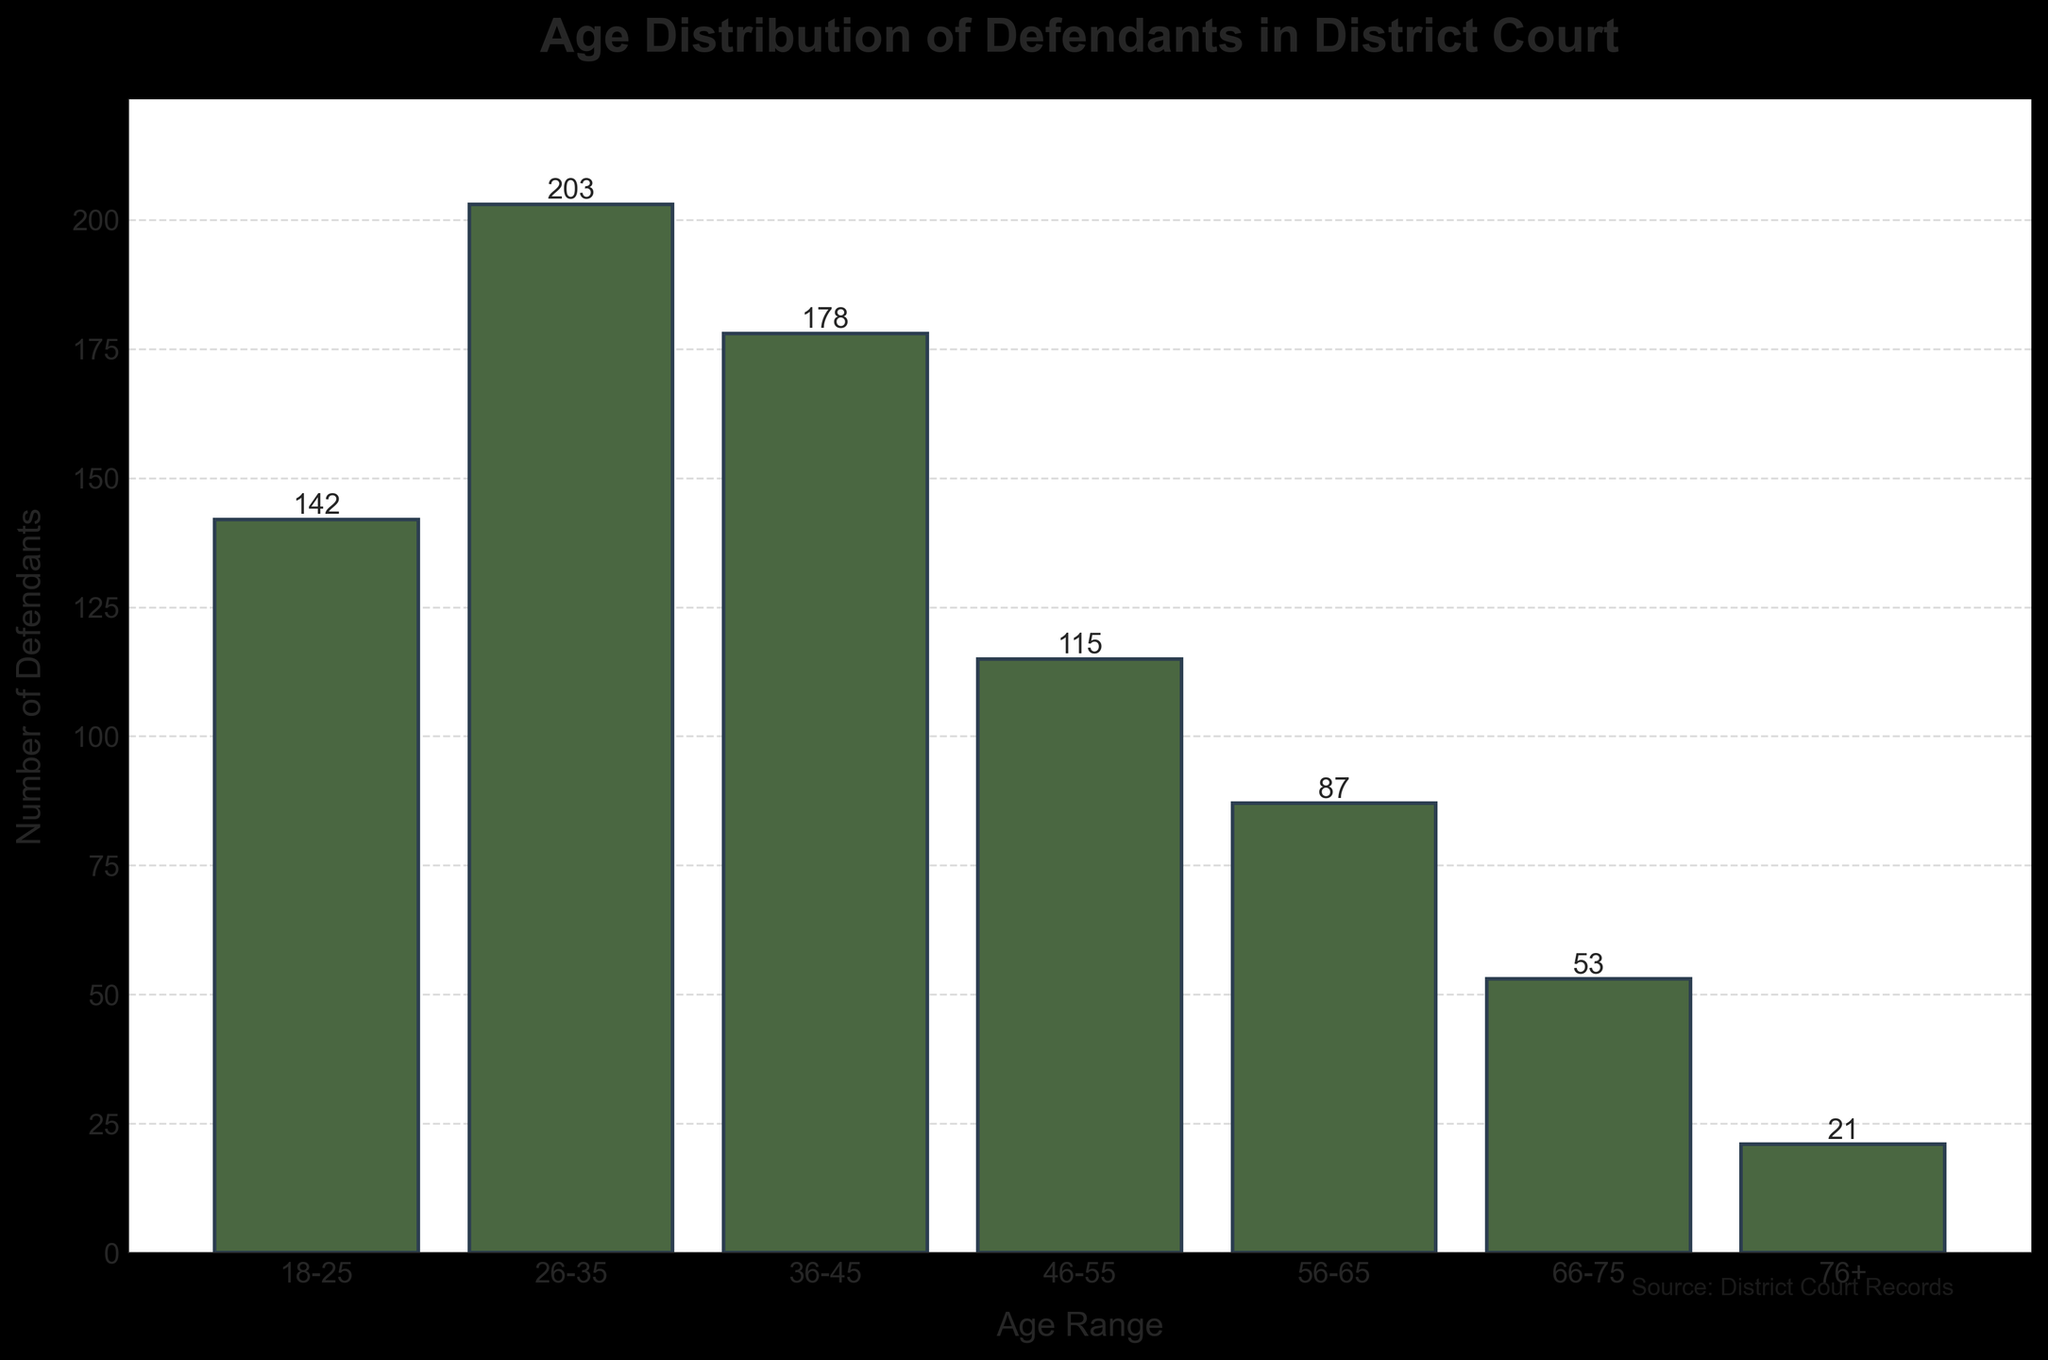What is the title of the histogram? The title of the histogram is typically the most prominent text at the top of the figure, providing a succinct summary of what the chart is about. In this case, it would be centered at the top.
Answer: Age Distribution of Defendants in District Court What age range has the highest number of defendants? To determine the age range with the highest number of defendants, compare the heights of the bars. The tallest bar represents the age range with the highest number.
Answer: 26-35 How many defendants are in the 46-55 age range? Refer to the bar labeled "46-55" and read the value either at the top of the bar or as labeled on the figure.
Answer: 115 Which age range has fewer than 100 defendants? Look for bars whose height corresponds to values less than 100 on the y-axis.
Answer: 56-65, 66-75, 76+ How many defendants are aged 56 and above? Sum the numbers of defendants in the age ranges 56-65, 66-75, and 76+: 87 + 53 + 21 = 161
Answer: 161 What is the combined number of defendants in the 18-25 and 36-45 age ranges? Add the numbers of defendants in the 18-25 and 36-45 age ranges: 142 + 178 = 320
Answer: 320 Which age range has the least number of defendants? Identify the shortest bar on the histogram, corresponding to the smallest value.
Answer: 76+ How many total defendants are represented in the histogram? Sum the numbers of defendants across all age ranges: 142 + 203 + 178 + 115 + 87 + 53 + 21 = 799
Answer: 799 What is the average number of defendants per age range? Calculate the total number of defendants and divide by the number of age ranges: 799 / 7 ≈ 114.14
Answer: 114.14 Is the number of defendants in the 26-35 age range greater than the number of defendants in the 36-45 and 46-55 age ranges combined? Sum the numbers of defendants in the 36-45 and 46-55 ranges and compare it to the number in the 26-35 range: 178 + 115 = 293, which is greater than 203.
Answer: No 